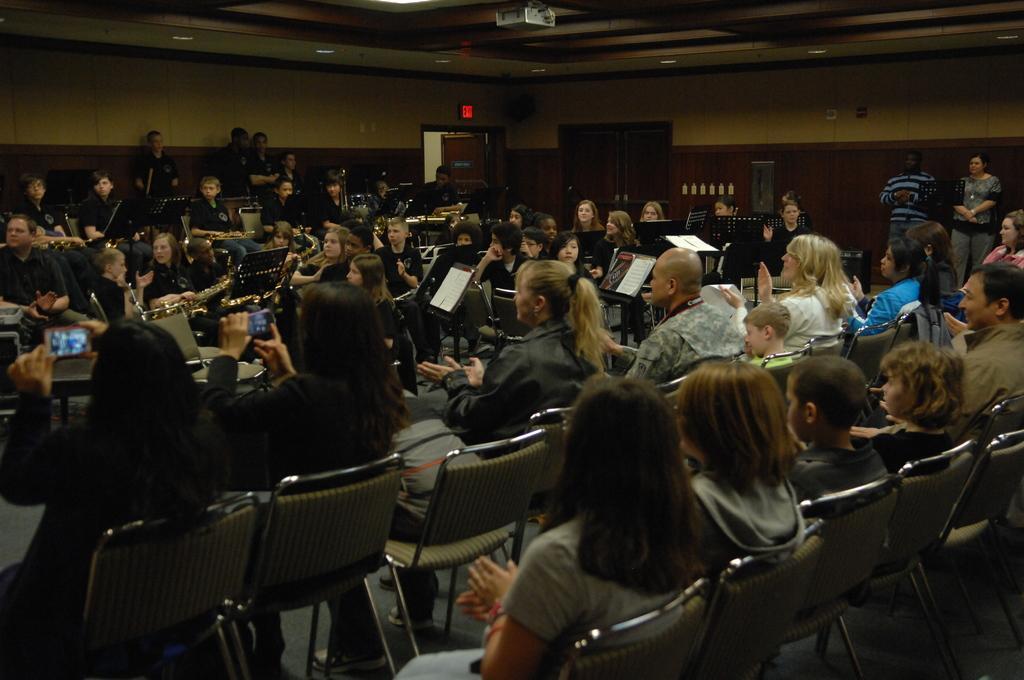Could you give a brief overview of what you see in this image? At the bottom of the image there are many people sitting on the chairs. In front of them there are few people sitting on the chairs. And in the background there is a wall with doors and few other items on it. At the top of the image there is a roof with projector. 